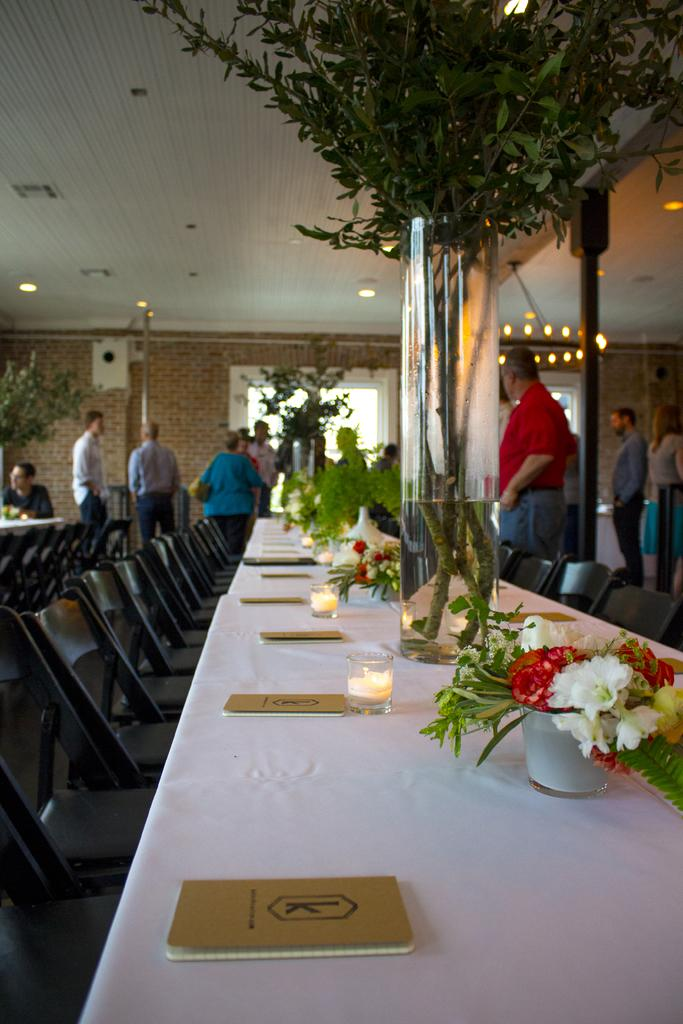What type of structure is visible in the image? There is a brick wall in the image. What type of vegetation is present in the image? There is a plant in the image. What type of furniture is visible in the image? There are tables and chairs in the image. What are the people in the image doing? There are people standing in the image. What items can be seen on the table in the image? On the table, there are books, flowers, and glasses. What type of competition is taking place in the image? There is no competition present in the image. What type of appliance can be seen on the table in the image? There are no appliances present on the table in the image. 